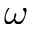Convert formula to latex. <formula><loc_0><loc_0><loc_500><loc_500>\omega</formula> 